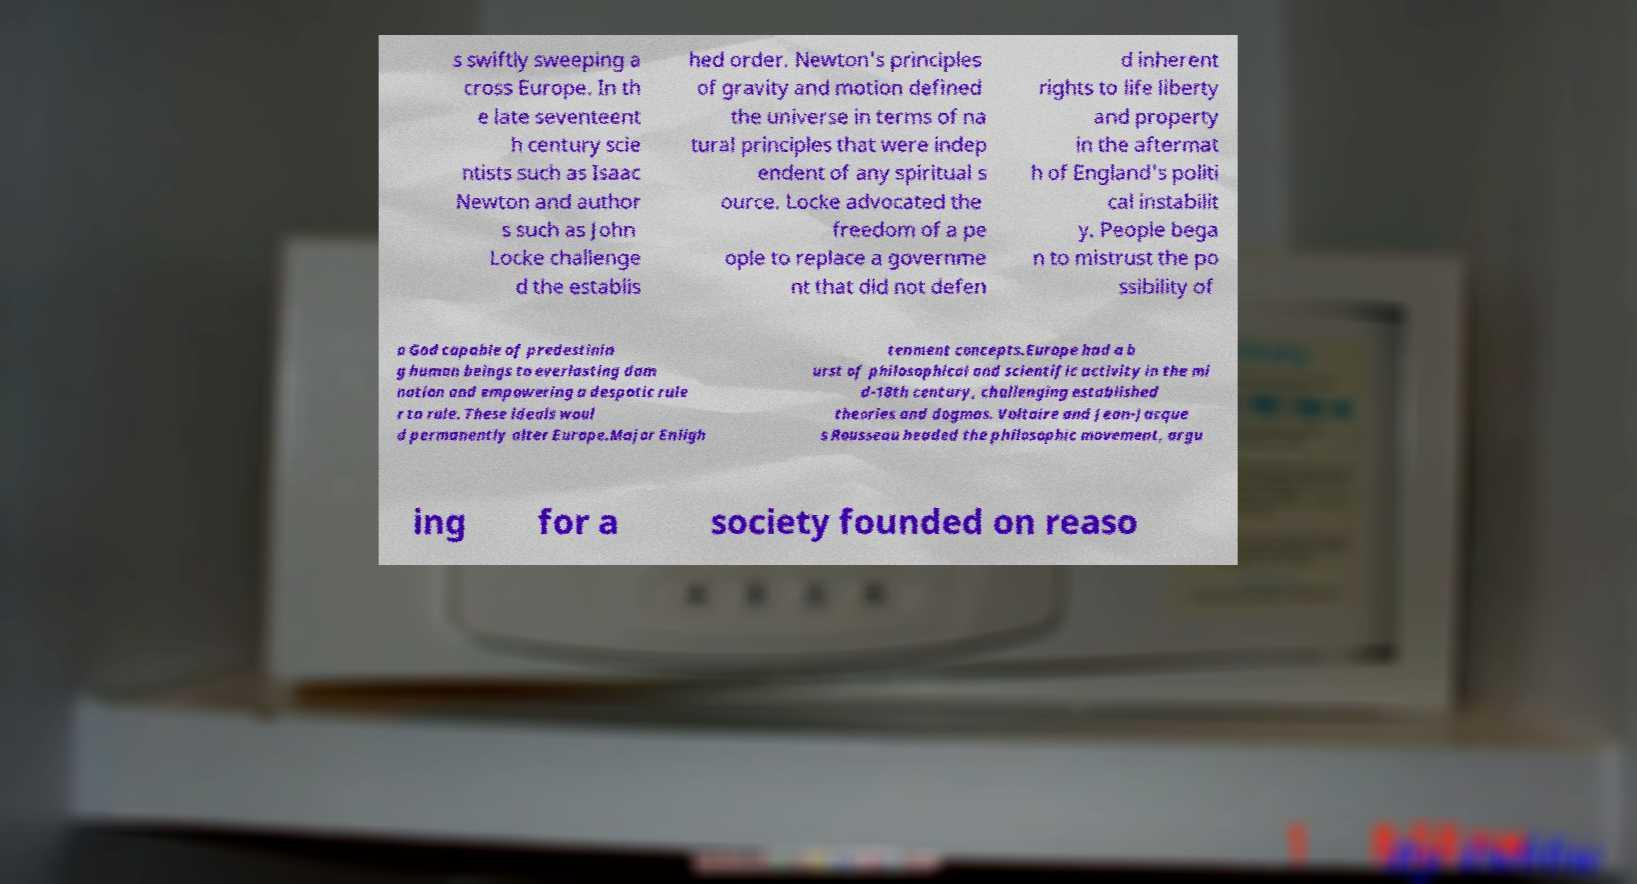Please identify and transcribe the text found in this image. s swiftly sweeping a cross Europe. In th e late seventeent h century scie ntists such as Isaac Newton and author s such as John Locke challenge d the establis hed order. Newton's principles of gravity and motion defined the universe in terms of na tural principles that were indep endent of any spiritual s ource. Locke advocated the freedom of a pe ople to replace a governme nt that did not defen d inherent rights to life liberty and property in the aftermat h of England's politi cal instabilit y. People bega n to mistrust the po ssibility of a God capable of predestinin g human beings to everlasting dam nation and empowering a despotic rule r to rule. These ideals woul d permanently alter Europe.Major Enligh tenment concepts.Europe had a b urst of philosophical and scientific activity in the mi d-18th century, challenging established theories and dogmas. Voltaire and Jean-Jacque s Rousseau headed the philosophic movement, argu ing for a society founded on reaso 